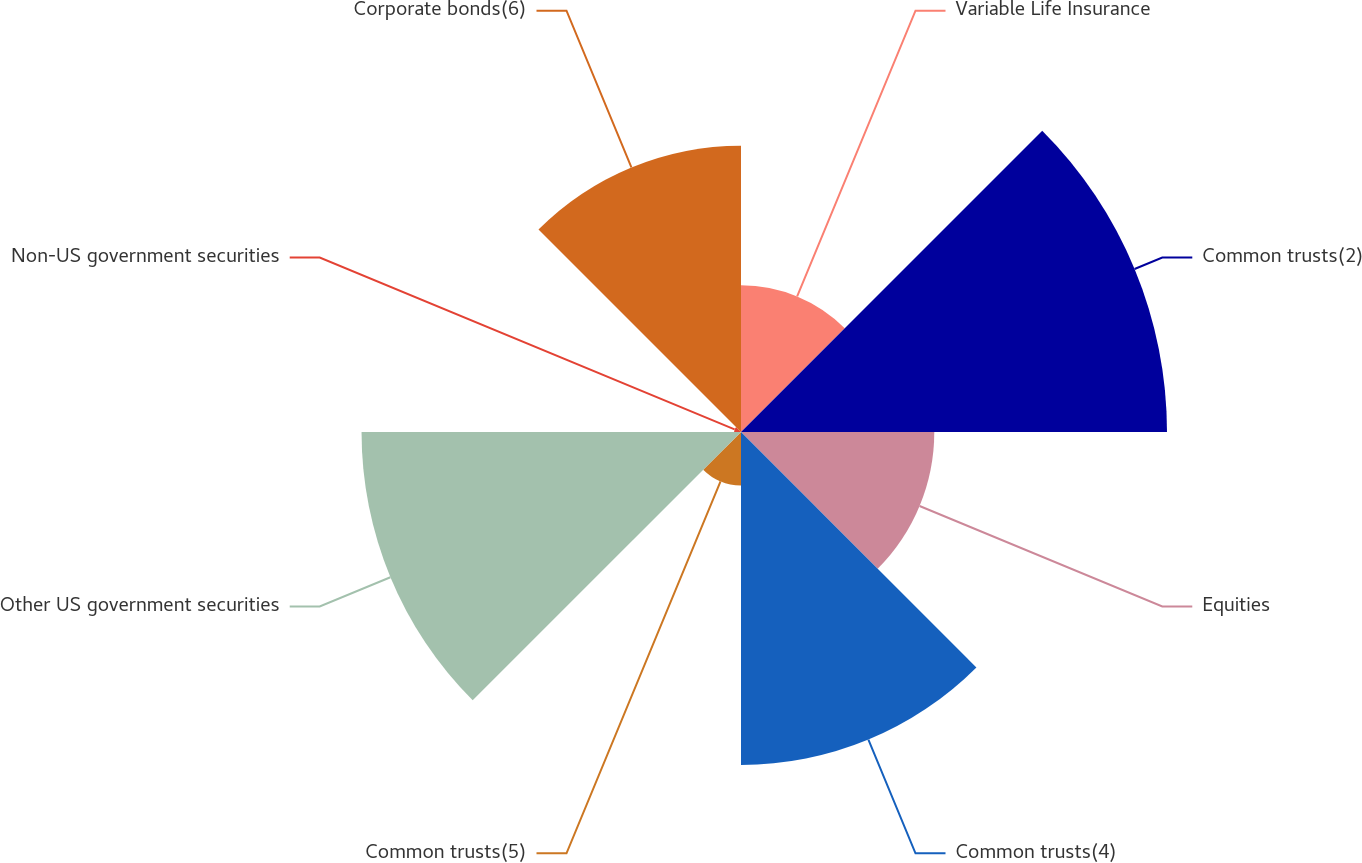<chart> <loc_0><loc_0><loc_500><loc_500><pie_chart><fcel>Variable Life Insurance<fcel>Common trusts(2)<fcel>Equities<fcel>Common trusts(4)<fcel>Common trusts(5)<fcel>Other US government securities<fcel>Non-US government securities<fcel>Corporate bonds(6)<nl><fcel>8.04%<fcel>23.34%<fcel>10.59%<fcel>18.24%<fcel>2.93%<fcel>20.79%<fcel>0.38%<fcel>15.69%<nl></chart> 